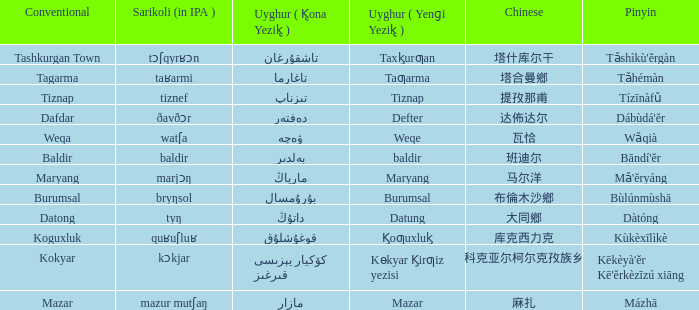Can you provide the standard practice for managing a defter? Dafdar. 